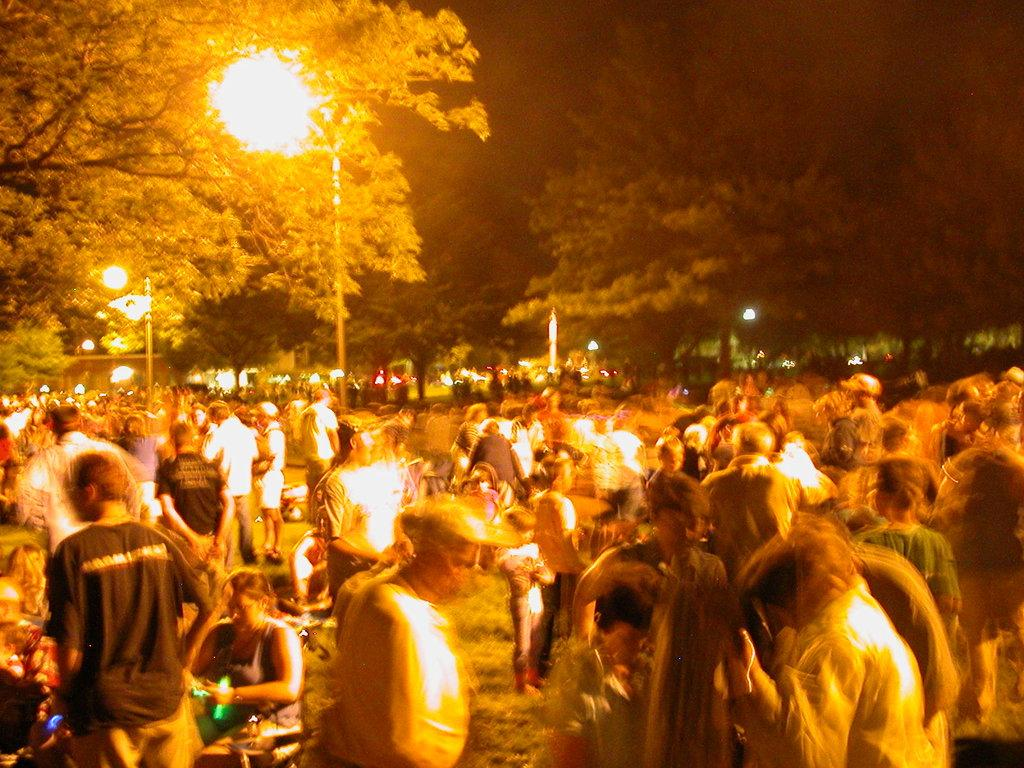How many individuals are present in the image? There are many people in the image. What are the people in the image doing? The people are waiting on the ground. What can be seen in the image that provides light? There is a street light visible in the image. What type of vegetation is visible in the background of the image? There are huge trees in the background of the image. What type of floor is visible in the image? The image does not show a specific type of floor; it only shows people waiting on the ground. 